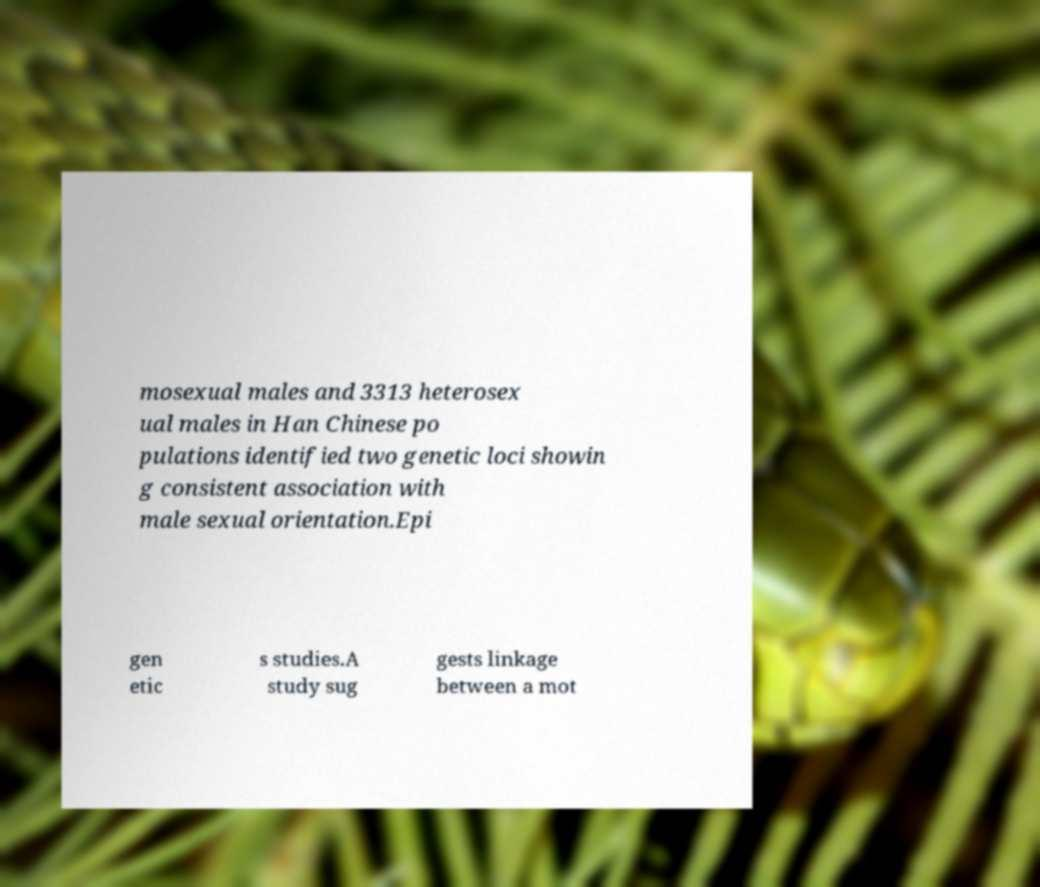What messages or text are displayed in this image? I need them in a readable, typed format. mosexual males and 3313 heterosex ual males in Han Chinese po pulations identified two genetic loci showin g consistent association with male sexual orientation.Epi gen etic s studies.A study sug gests linkage between a mot 